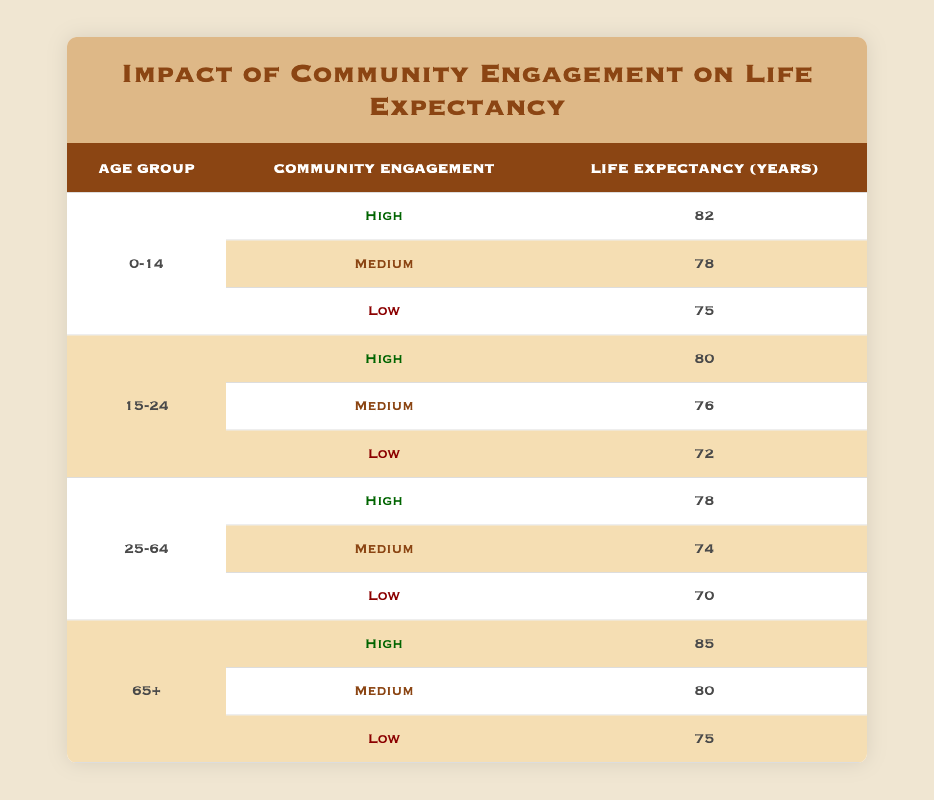What is the life expectancy for children aged 0-14 with high community engagement? According to the table, children aged 0-14 with high community engagement have a life expectancy of 82 years.
Answer: 82 What is the difference in life expectancy between medium and low community engagement for the age group of 15-24? The life expectancy for medium community engagement in the 15-24 age group is 76 years, while for low it is 72 years. The difference is 76 - 72 = 4 years.
Answer: 4 Does the life expectancy for seniors aged 65 and above decline when community engagement decreases from high to low? Yes, seniors aged 65 and above have a life expectancy of 85 years with high community engagement, which decreases to 75 years with low engagement.
Answer: Yes What is the average life expectancy across all age groups when community engagement is high? The life expectancies for high community engagement are 82 (0-14), 80 (15-24), 78 (25-64), and 85 (65+). Summing these gives 82 + 80 + 78 + 85 = 325. There are 4 data points, so the average is 325 / 4 = 81.25.
Answer: 81.25 Does community engagement appear to have a more significant impact on life expectancy for younger or older age groups based on the data? To determine this, we can compare the life expectancy changes: For ages 0-14, life expectancies are 82 (high), 78 (medium), 75 (low). For ages 65+, they are 85 (high), 80 (medium), and 75 (low). The impact is 7 years for younger and 10 years for older age groups upon lowering engagement from high to low. Since the impact is greater for the older age group, the answer is that it has a more significant impact on older individuals.
Answer: Older age groups What is the life expectancy for individuals aged 25-64 with medium community engagement? The life expectancy for the 25-64 age group with medium community engagement is 74 years as stated in the table.
Answer: 74 Is the life expectancy for the age group of 15-24 with low community engagement higher than for the age group of 0-14 with low engagement? Yes, the life expectancy for the 15-24 age group with low community engagement is 72 years, while for the 0-14 age group it is 75 years. However, clearly, 75 is not lower than 72, making the statement false.
Answer: No 